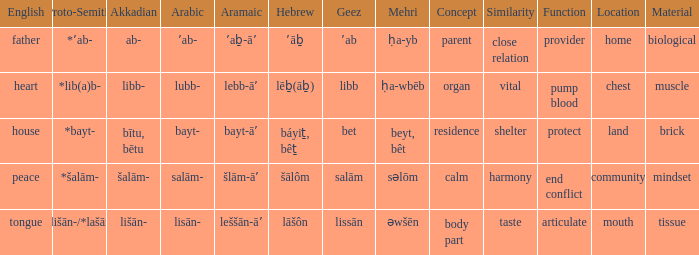If the aramaic is šlām-āʼ, what is the english? Peace. 